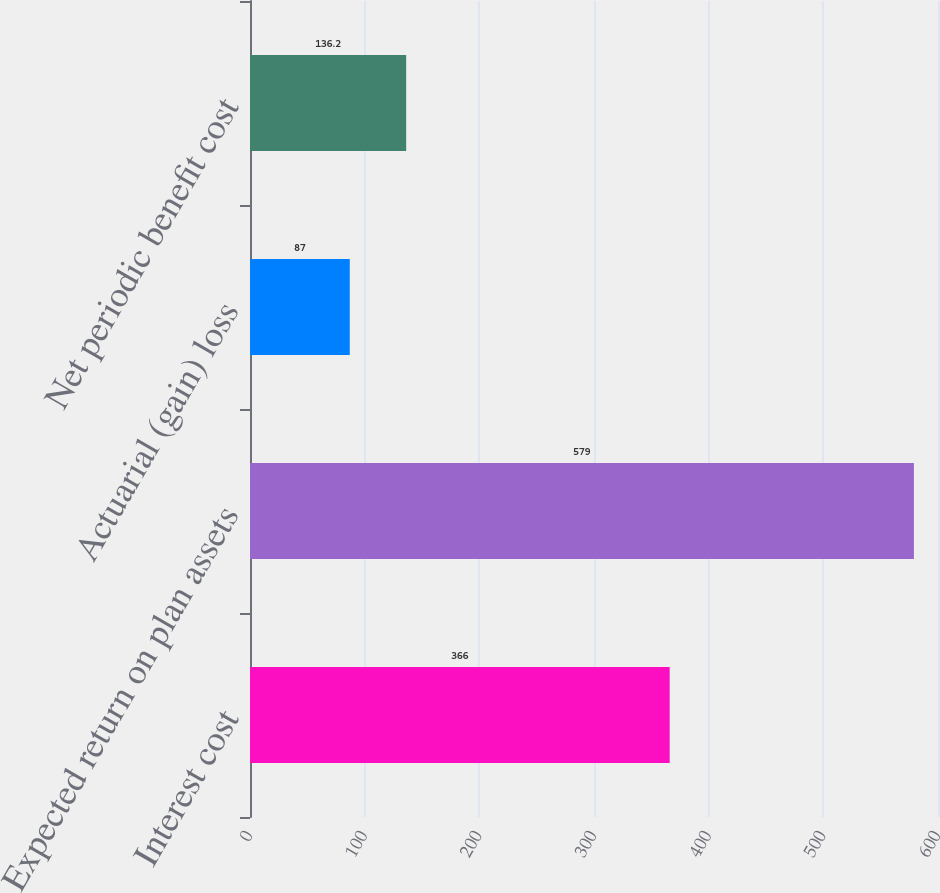Convert chart to OTSL. <chart><loc_0><loc_0><loc_500><loc_500><bar_chart><fcel>Interest cost<fcel>Expected return on plan assets<fcel>Actuarial (gain) loss<fcel>Net periodic benefit cost<nl><fcel>366<fcel>579<fcel>87<fcel>136.2<nl></chart> 